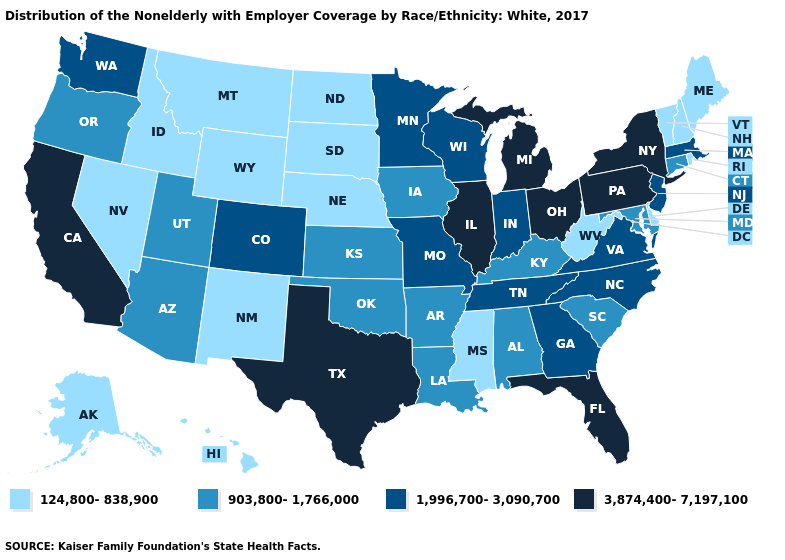What is the value of Pennsylvania?
Answer briefly. 3,874,400-7,197,100. Which states hav the highest value in the Northeast?
Concise answer only. New York, Pennsylvania. Name the states that have a value in the range 124,800-838,900?
Be succinct. Alaska, Delaware, Hawaii, Idaho, Maine, Mississippi, Montana, Nebraska, Nevada, New Hampshire, New Mexico, North Dakota, Rhode Island, South Dakota, Vermont, West Virginia, Wyoming. Name the states that have a value in the range 3,874,400-7,197,100?
Short answer required. California, Florida, Illinois, Michigan, New York, Ohio, Pennsylvania, Texas. What is the lowest value in states that border Wyoming?
Keep it brief. 124,800-838,900. What is the value of Illinois?
Concise answer only. 3,874,400-7,197,100. Which states hav the highest value in the MidWest?
Write a very short answer. Illinois, Michigan, Ohio. What is the lowest value in the USA?
Quick response, please. 124,800-838,900. What is the value of Iowa?
Be succinct. 903,800-1,766,000. What is the value of Missouri?
Be succinct. 1,996,700-3,090,700. Which states have the lowest value in the USA?
Answer briefly. Alaska, Delaware, Hawaii, Idaho, Maine, Mississippi, Montana, Nebraska, Nevada, New Hampshire, New Mexico, North Dakota, Rhode Island, South Dakota, Vermont, West Virginia, Wyoming. Which states have the lowest value in the West?
Short answer required. Alaska, Hawaii, Idaho, Montana, Nevada, New Mexico, Wyoming. Does Vermont have the highest value in the Northeast?
Concise answer only. No. Among the states that border South Dakota , does Minnesota have the highest value?
Answer briefly. Yes. Which states hav the highest value in the Northeast?
Short answer required. New York, Pennsylvania. 